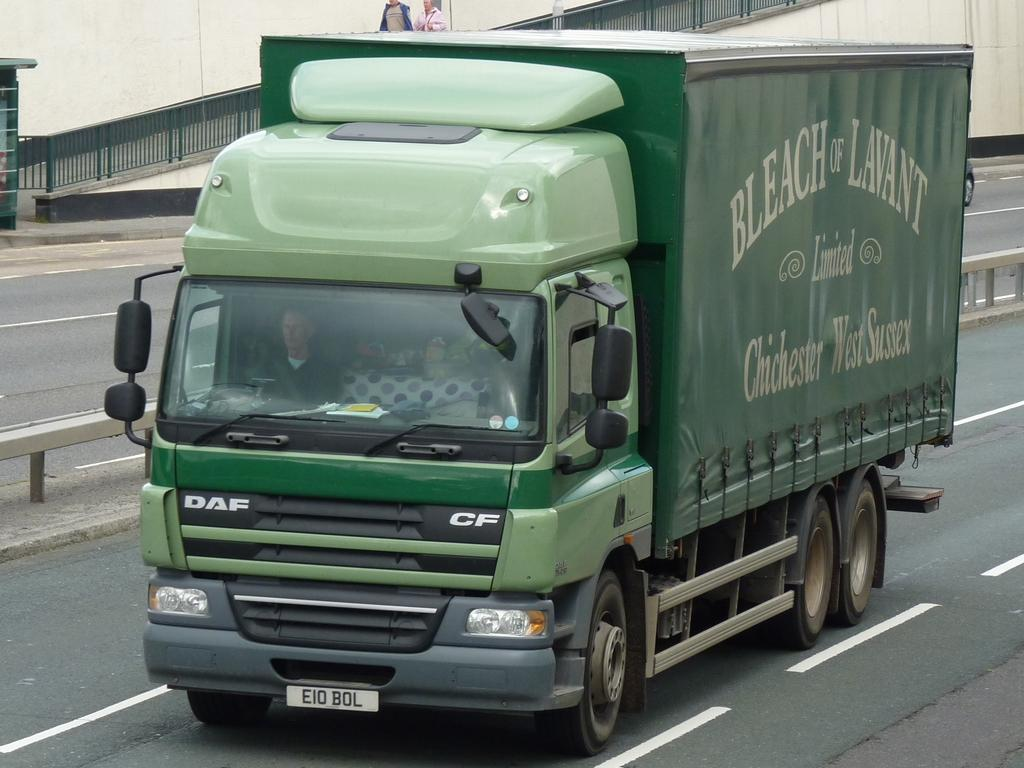What color is the truck in the image? The truck in the image is green. Where is the truck located in the image? The truck is on the road. What can be seen in the background of the image? There is a black color railing in the background of the image. Are there any bears using the railing in the image? There are no bears present in the image, and therefore they cannot be using the railing. 